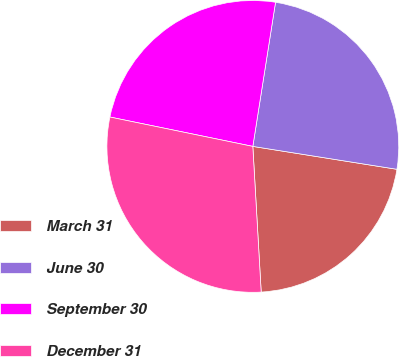Convert chart to OTSL. <chart><loc_0><loc_0><loc_500><loc_500><pie_chart><fcel>March 31<fcel>June 30<fcel>September 30<fcel>December 31<nl><fcel>21.58%<fcel>25.02%<fcel>24.26%<fcel>29.14%<nl></chart> 